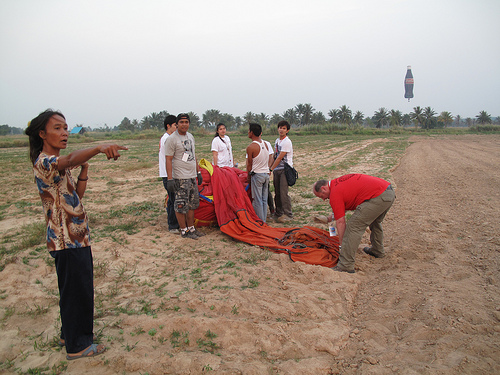<image>
Is the pant leg next to the house? No. The pant leg is not positioned next to the house. They are located in different areas of the scene. 